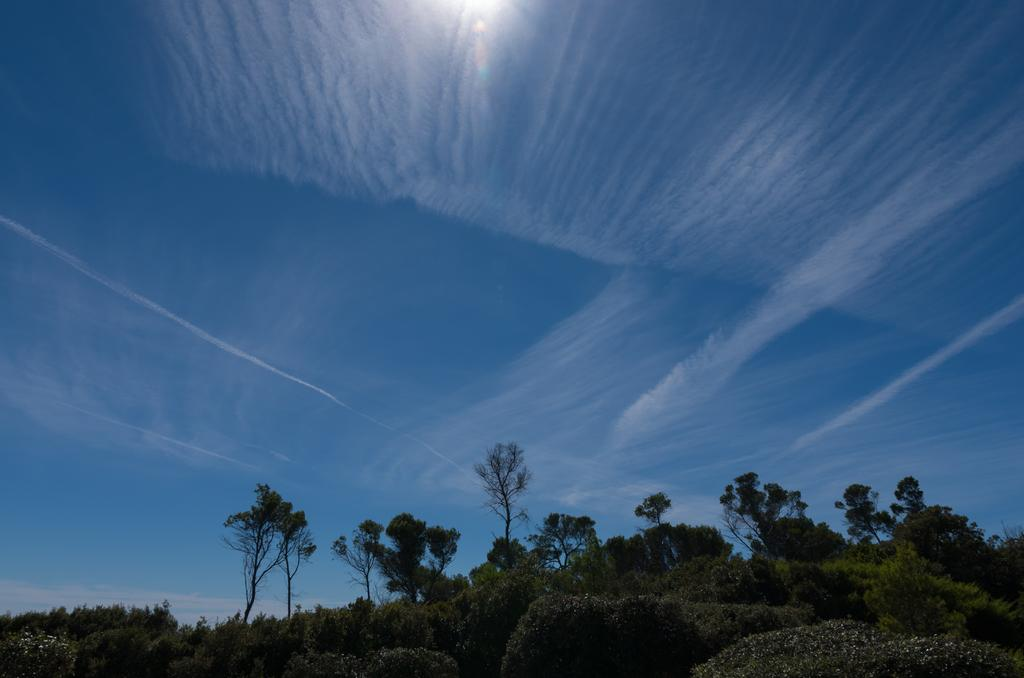What type of vegetation is located at the bottom of the picture? There are bushes at the bottom of the picture. What can be seen in the background of the image? There are plants and trees in the background of the image. What is the color of the sky in the image? The sky is blue in color. Can you see any flowers with a collar and veil in the image? There are no flowers, collars, or veils present in the image. 